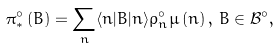<formula> <loc_0><loc_0><loc_500><loc_500>\pi _ { * } ^ { \circ } \left ( B \right ) = \sum _ { n } \langle n | B | n \rangle \rho _ { n } ^ { \circ } \mu \left ( n \right ) , \, B \in \mathcal { B } ^ { \circ } ,</formula> 